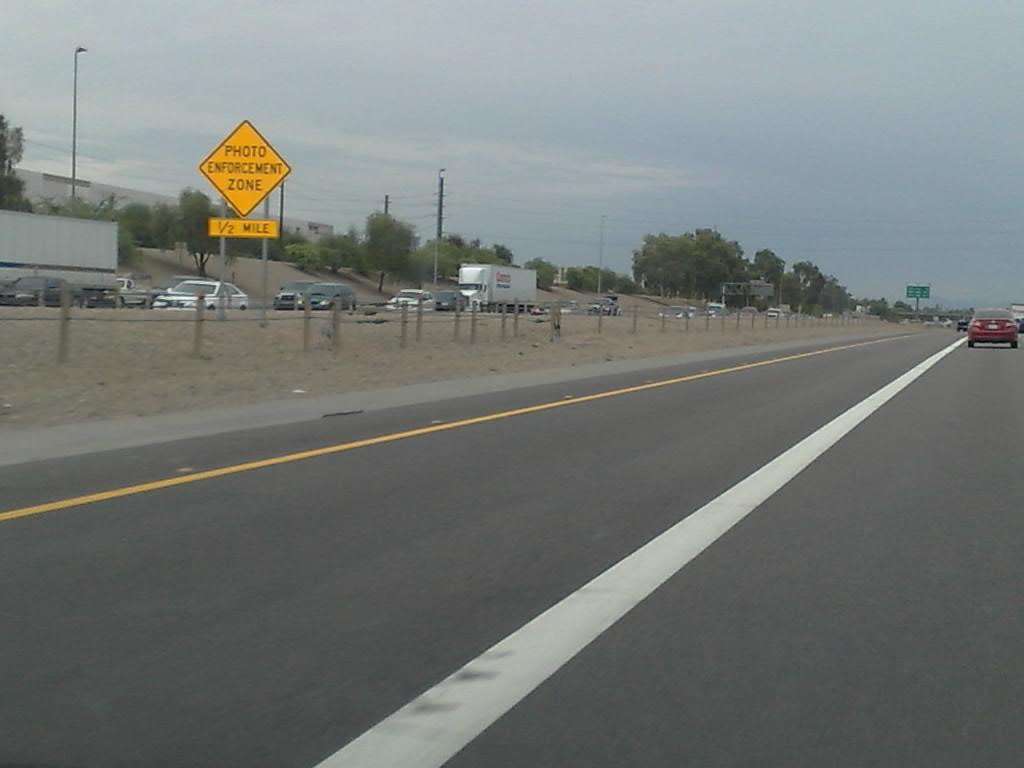What kind of zone does the traffic sign mention this area is?
Give a very brief answer. Photo enforcement zone. How long does the enforcement zone last?
Your response must be concise. 1/2 mile. 